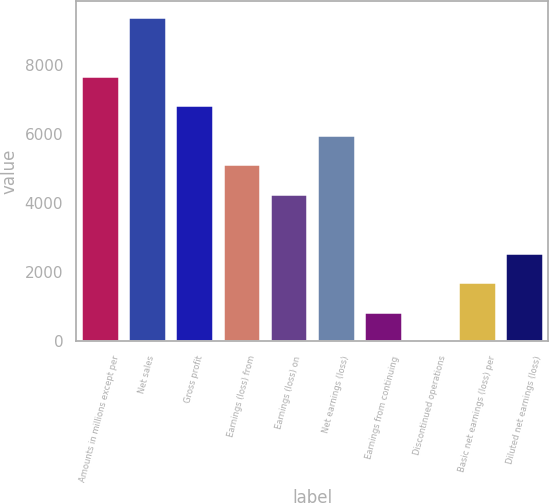Convert chart. <chart><loc_0><loc_0><loc_500><loc_500><bar_chart><fcel>Amounts in millions except per<fcel>Net sales<fcel>Gross profit<fcel>Earnings (loss) from<fcel>Earnings (loss) on<fcel>Net earnings (loss)<fcel>Earnings from continuing<fcel>Discontinued operations<fcel>Basic net earnings (loss) per<fcel>Diluted net earnings (loss)<nl><fcel>7672.41<fcel>9377.37<fcel>6819.93<fcel>5114.97<fcel>4262.49<fcel>5967.45<fcel>852.57<fcel>0.09<fcel>1705.05<fcel>2557.53<nl></chart> 